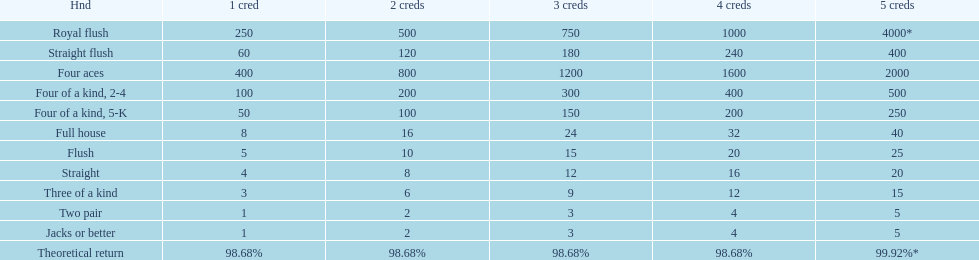Is four 5s worth more or less than four 2s? Less. 